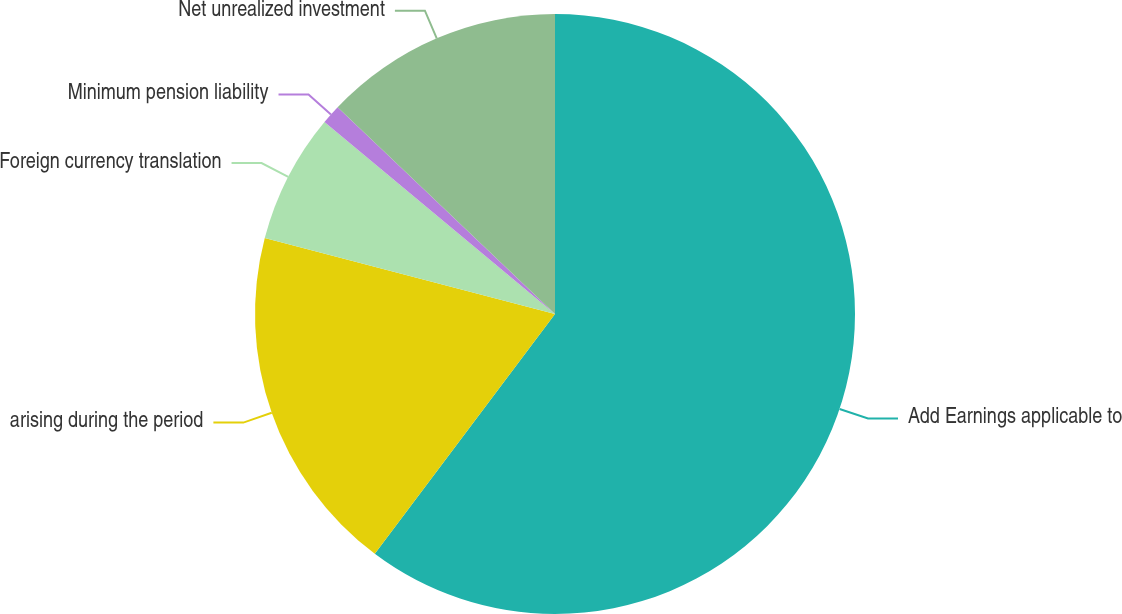Convert chart to OTSL. <chart><loc_0><loc_0><loc_500><loc_500><pie_chart><fcel>Add Earnings applicable to<fcel>arising during the period<fcel>Foreign currency translation<fcel>Minimum pension liability<fcel>Net unrealized investment<nl><fcel>60.26%<fcel>18.82%<fcel>6.98%<fcel>1.05%<fcel>12.9%<nl></chart> 